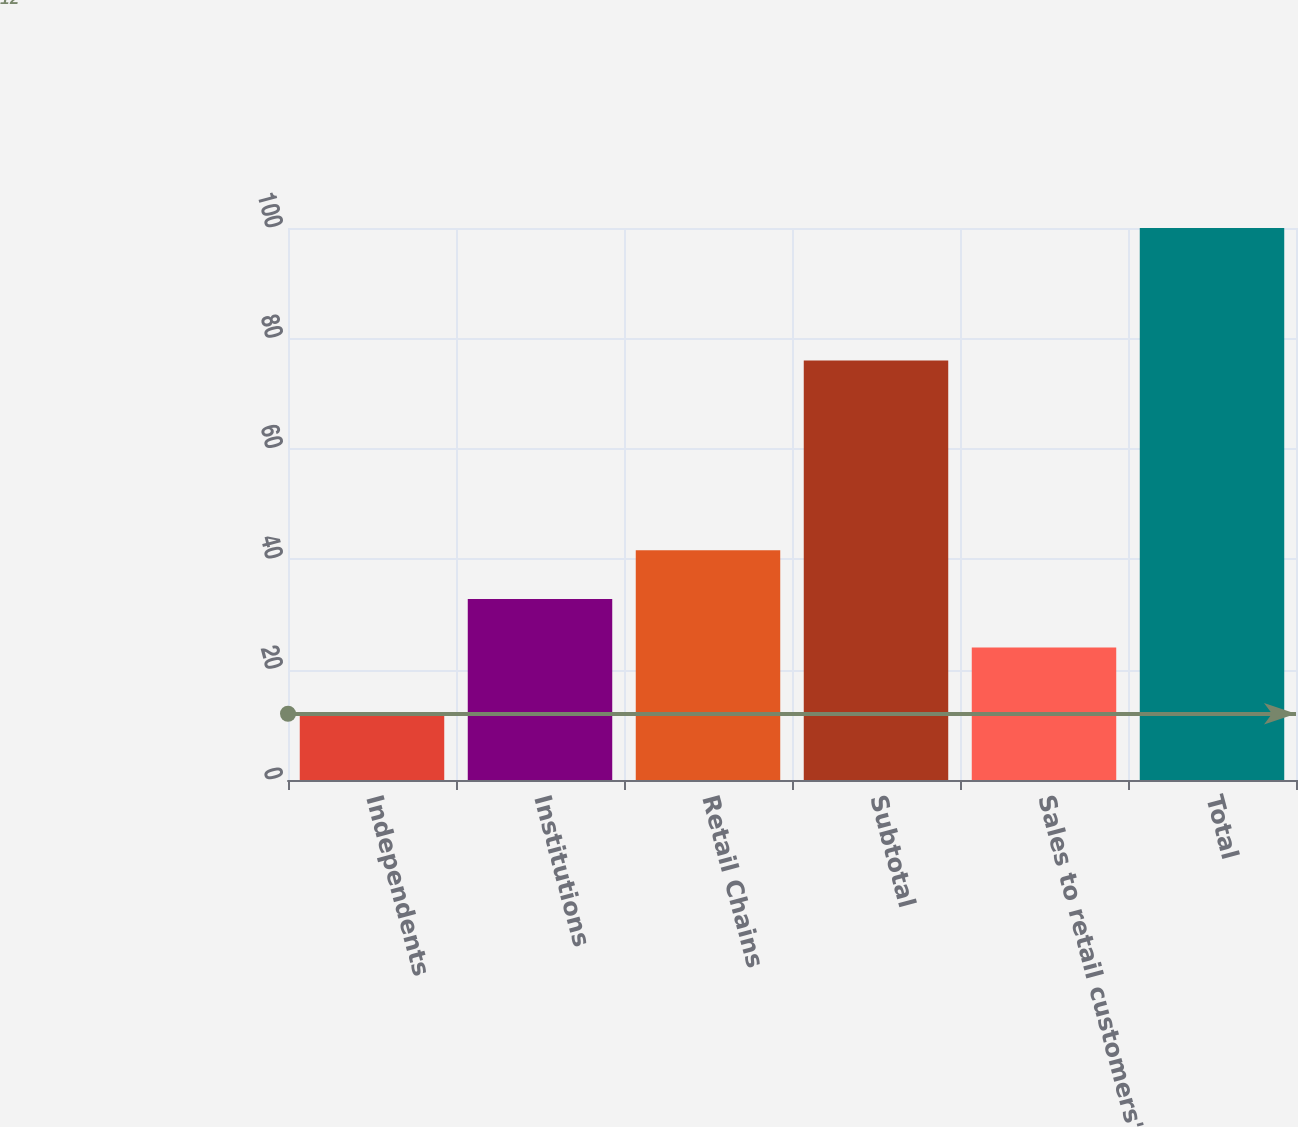<chart> <loc_0><loc_0><loc_500><loc_500><bar_chart><fcel>Independents<fcel>Institutions<fcel>Retail Chains<fcel>Subtotal<fcel>Sales to retail customers'<fcel>Total<nl><fcel>12<fcel>32.8<fcel>41.6<fcel>76<fcel>24<fcel>100<nl></chart> 